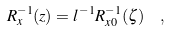Convert formula to latex. <formula><loc_0><loc_0><loc_500><loc_500>R _ { x } ^ { - 1 } ( z ) = l ^ { - 1 } R _ { x 0 } ^ { - 1 } ( \zeta ) \ \ ,</formula> 